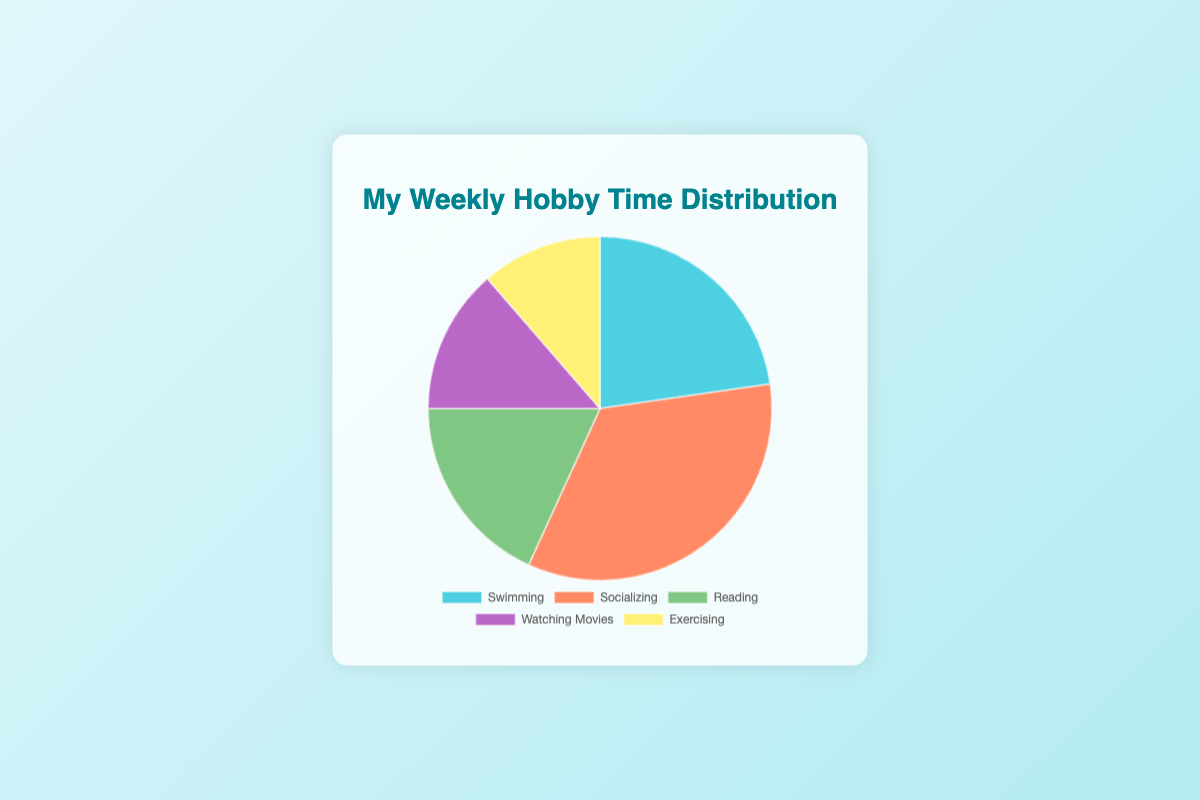What's the total time spent on Reading and Swimming? Add the time spent on Reading and Swimming: Reading = 8 hours and Swimming = 10 hours. So, 8 + 10 = 18
Answer: 18 Which hobby takes up the most time? Compare the time spent on each hobby. Socializing takes 15 hours, which is the highest among the given hobbies.
Answer: Socializing What percentage of the total time is spent on Exercising? First, calculate the total time spent on all hobbies: 10 + 15 + 8 + 6 + 5 = 44 hours. Then find the percentage for Exercising: (5 / 44) * 100 ≈ 11.36%
Answer: 11.36% How many more hours are spent on Socializing compared to Exercising? Subtract the time spent on Exercising from the time spent on Socializing: 15 - 5 = 10
Answer: 10 What is the difference in time spent between the hobby you spend the least time on and the hobby you spend the most time on? Identify the minimum and maximum time spent: Exercising is 5 hours, and Socializing is 15 hours. Subtract the minimum from the maximum: 15 - 5 = 10
Answer: 10 What color represents Swimming in the chart? Based on the data and usual color-coding practices, Swimming is represented by the color light blue.
Answer: Light blue What's the average time spent on Swimming and Watching Movies? Add the time spent on Swimming and Watching Movies: Swimming = 10 hours, Watching Movies = 6 hours. Then divide by 2: (10 + 6) / 2 = 8
Answer: 8 Is more time spent on Reading or Watching Movies? Compare the time spent on Reading and Watching Movies: Reading = 8 hours, Watching Movies = 6 hours. Reading is greater.
Answer: Reading What fraction of the total time is spent on Watching Movies? Calculate the total time: 10 + 15 + 8 + 6 + 5 = 44 hours. Then find the fraction for Watching Movies: 6 / 44 = 3 / 22
Answer: 3/22 If you had to spend 3 more hours on Exercising, how much would the total time spent on all hobbies become? Current total time is 44 hours. Adding 3 more hours to Exercising: 5 + 3 = 8 hours. New total time: 44 + 3 = 47 hours
Answer: 47 